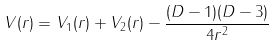<formula> <loc_0><loc_0><loc_500><loc_500>V ( r ) = V _ { 1 } ( r ) + V _ { 2 } ( r ) - \frac { ( D - 1 ) ( D - 3 ) } { 4 r ^ { 2 } }</formula> 